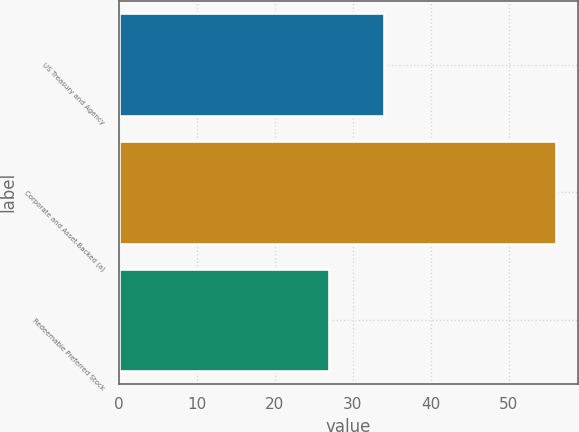Convert chart to OTSL. <chart><loc_0><loc_0><loc_500><loc_500><bar_chart><fcel>US Treasury and Agency<fcel>Corporate and Asset-Backed (a)<fcel>Redeemable Preferred Stock<nl><fcel>34<fcel>56<fcel>27<nl></chart> 